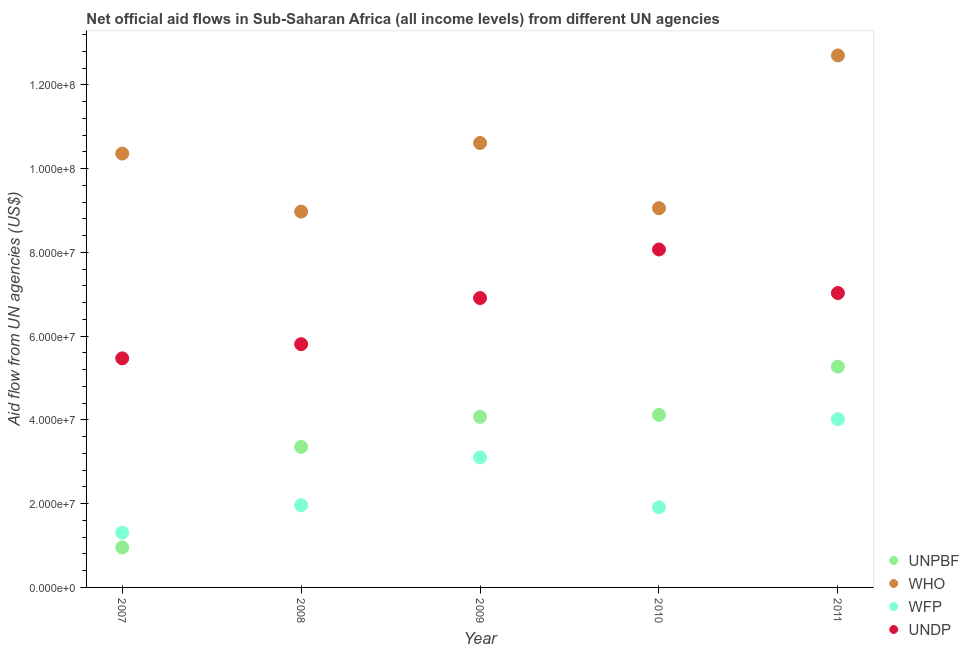What is the amount of aid given by unpbf in 2011?
Your response must be concise. 5.27e+07. Across all years, what is the maximum amount of aid given by who?
Make the answer very short. 1.27e+08. Across all years, what is the minimum amount of aid given by who?
Give a very brief answer. 8.98e+07. What is the total amount of aid given by who in the graph?
Make the answer very short. 5.17e+08. What is the difference between the amount of aid given by who in 2007 and that in 2009?
Offer a very short reply. -2.53e+06. What is the difference between the amount of aid given by unpbf in 2011 and the amount of aid given by undp in 2007?
Ensure brevity in your answer.  -1.98e+06. What is the average amount of aid given by wfp per year?
Give a very brief answer. 2.46e+07. In the year 2010, what is the difference between the amount of aid given by who and amount of aid given by undp?
Keep it short and to the point. 9.86e+06. In how many years, is the amount of aid given by who greater than 120000000 US$?
Offer a terse response. 1. What is the ratio of the amount of aid given by wfp in 2007 to that in 2010?
Ensure brevity in your answer.  0.68. Is the difference between the amount of aid given by undp in 2007 and 2009 greater than the difference between the amount of aid given by wfp in 2007 and 2009?
Provide a succinct answer. Yes. What is the difference between the highest and the second highest amount of aid given by unpbf?
Make the answer very short. 1.15e+07. What is the difference between the highest and the lowest amount of aid given by unpbf?
Keep it short and to the point. 4.32e+07. In how many years, is the amount of aid given by wfp greater than the average amount of aid given by wfp taken over all years?
Your answer should be very brief. 2. Is the sum of the amount of aid given by undp in 2010 and 2011 greater than the maximum amount of aid given by unpbf across all years?
Keep it short and to the point. Yes. Does the amount of aid given by undp monotonically increase over the years?
Your answer should be compact. No. Is the amount of aid given by unpbf strictly greater than the amount of aid given by who over the years?
Your answer should be compact. No. How many years are there in the graph?
Provide a short and direct response. 5. What is the difference between two consecutive major ticks on the Y-axis?
Your response must be concise. 2.00e+07. Are the values on the major ticks of Y-axis written in scientific E-notation?
Offer a very short reply. Yes. Where does the legend appear in the graph?
Offer a very short reply. Bottom right. How are the legend labels stacked?
Keep it short and to the point. Vertical. What is the title of the graph?
Give a very brief answer. Net official aid flows in Sub-Saharan Africa (all income levels) from different UN agencies. What is the label or title of the X-axis?
Ensure brevity in your answer.  Year. What is the label or title of the Y-axis?
Your answer should be compact. Aid flow from UN agencies (US$). What is the Aid flow from UN agencies (US$) of UNPBF in 2007?
Provide a short and direct response. 9.55e+06. What is the Aid flow from UN agencies (US$) in WHO in 2007?
Keep it short and to the point. 1.04e+08. What is the Aid flow from UN agencies (US$) of WFP in 2007?
Your response must be concise. 1.31e+07. What is the Aid flow from UN agencies (US$) of UNDP in 2007?
Provide a succinct answer. 5.47e+07. What is the Aid flow from UN agencies (US$) of UNPBF in 2008?
Keep it short and to the point. 3.36e+07. What is the Aid flow from UN agencies (US$) of WHO in 2008?
Give a very brief answer. 8.98e+07. What is the Aid flow from UN agencies (US$) of WFP in 2008?
Offer a very short reply. 1.96e+07. What is the Aid flow from UN agencies (US$) of UNDP in 2008?
Offer a terse response. 5.81e+07. What is the Aid flow from UN agencies (US$) in UNPBF in 2009?
Keep it short and to the point. 4.07e+07. What is the Aid flow from UN agencies (US$) of WHO in 2009?
Your answer should be very brief. 1.06e+08. What is the Aid flow from UN agencies (US$) in WFP in 2009?
Provide a succinct answer. 3.10e+07. What is the Aid flow from UN agencies (US$) of UNDP in 2009?
Provide a succinct answer. 6.91e+07. What is the Aid flow from UN agencies (US$) in UNPBF in 2010?
Offer a terse response. 4.12e+07. What is the Aid flow from UN agencies (US$) of WHO in 2010?
Make the answer very short. 9.06e+07. What is the Aid flow from UN agencies (US$) in WFP in 2010?
Your answer should be compact. 1.91e+07. What is the Aid flow from UN agencies (US$) in UNDP in 2010?
Your answer should be very brief. 8.07e+07. What is the Aid flow from UN agencies (US$) of UNPBF in 2011?
Give a very brief answer. 5.27e+07. What is the Aid flow from UN agencies (US$) in WHO in 2011?
Offer a very short reply. 1.27e+08. What is the Aid flow from UN agencies (US$) of WFP in 2011?
Ensure brevity in your answer.  4.02e+07. What is the Aid flow from UN agencies (US$) of UNDP in 2011?
Your answer should be compact. 7.03e+07. Across all years, what is the maximum Aid flow from UN agencies (US$) of UNPBF?
Your answer should be compact. 5.27e+07. Across all years, what is the maximum Aid flow from UN agencies (US$) in WHO?
Your answer should be compact. 1.27e+08. Across all years, what is the maximum Aid flow from UN agencies (US$) in WFP?
Your response must be concise. 4.02e+07. Across all years, what is the maximum Aid flow from UN agencies (US$) of UNDP?
Ensure brevity in your answer.  8.07e+07. Across all years, what is the minimum Aid flow from UN agencies (US$) of UNPBF?
Your response must be concise. 9.55e+06. Across all years, what is the minimum Aid flow from UN agencies (US$) of WHO?
Make the answer very short. 8.98e+07. Across all years, what is the minimum Aid flow from UN agencies (US$) in WFP?
Ensure brevity in your answer.  1.31e+07. Across all years, what is the minimum Aid flow from UN agencies (US$) of UNDP?
Give a very brief answer. 5.47e+07. What is the total Aid flow from UN agencies (US$) of UNPBF in the graph?
Give a very brief answer. 1.78e+08. What is the total Aid flow from UN agencies (US$) of WHO in the graph?
Your response must be concise. 5.17e+08. What is the total Aid flow from UN agencies (US$) in WFP in the graph?
Your answer should be very brief. 1.23e+08. What is the total Aid flow from UN agencies (US$) in UNDP in the graph?
Your answer should be very brief. 3.33e+08. What is the difference between the Aid flow from UN agencies (US$) in UNPBF in 2007 and that in 2008?
Offer a very short reply. -2.40e+07. What is the difference between the Aid flow from UN agencies (US$) in WHO in 2007 and that in 2008?
Offer a very short reply. 1.39e+07. What is the difference between the Aid flow from UN agencies (US$) of WFP in 2007 and that in 2008?
Give a very brief answer. -6.53e+06. What is the difference between the Aid flow from UN agencies (US$) of UNDP in 2007 and that in 2008?
Your response must be concise. -3.39e+06. What is the difference between the Aid flow from UN agencies (US$) of UNPBF in 2007 and that in 2009?
Your answer should be compact. -3.12e+07. What is the difference between the Aid flow from UN agencies (US$) of WHO in 2007 and that in 2009?
Ensure brevity in your answer.  -2.53e+06. What is the difference between the Aid flow from UN agencies (US$) of WFP in 2007 and that in 2009?
Offer a very short reply. -1.80e+07. What is the difference between the Aid flow from UN agencies (US$) of UNDP in 2007 and that in 2009?
Make the answer very short. -1.44e+07. What is the difference between the Aid flow from UN agencies (US$) of UNPBF in 2007 and that in 2010?
Provide a short and direct response. -3.17e+07. What is the difference between the Aid flow from UN agencies (US$) in WHO in 2007 and that in 2010?
Keep it short and to the point. 1.30e+07. What is the difference between the Aid flow from UN agencies (US$) in WFP in 2007 and that in 2010?
Your response must be concise. -6.06e+06. What is the difference between the Aid flow from UN agencies (US$) of UNDP in 2007 and that in 2010?
Provide a succinct answer. -2.60e+07. What is the difference between the Aid flow from UN agencies (US$) of UNPBF in 2007 and that in 2011?
Ensure brevity in your answer.  -4.32e+07. What is the difference between the Aid flow from UN agencies (US$) of WHO in 2007 and that in 2011?
Keep it short and to the point. -2.34e+07. What is the difference between the Aid flow from UN agencies (US$) in WFP in 2007 and that in 2011?
Offer a very short reply. -2.71e+07. What is the difference between the Aid flow from UN agencies (US$) in UNDP in 2007 and that in 2011?
Provide a short and direct response. -1.56e+07. What is the difference between the Aid flow from UN agencies (US$) in UNPBF in 2008 and that in 2009?
Provide a succinct answer. -7.17e+06. What is the difference between the Aid flow from UN agencies (US$) in WHO in 2008 and that in 2009?
Your answer should be very brief. -1.64e+07. What is the difference between the Aid flow from UN agencies (US$) in WFP in 2008 and that in 2009?
Your response must be concise. -1.14e+07. What is the difference between the Aid flow from UN agencies (US$) of UNDP in 2008 and that in 2009?
Make the answer very short. -1.10e+07. What is the difference between the Aid flow from UN agencies (US$) of UNPBF in 2008 and that in 2010?
Keep it short and to the point. -7.64e+06. What is the difference between the Aid flow from UN agencies (US$) of WHO in 2008 and that in 2010?
Ensure brevity in your answer.  -8.10e+05. What is the difference between the Aid flow from UN agencies (US$) of UNDP in 2008 and that in 2010?
Make the answer very short. -2.26e+07. What is the difference between the Aid flow from UN agencies (US$) in UNPBF in 2008 and that in 2011?
Make the answer very short. -1.92e+07. What is the difference between the Aid flow from UN agencies (US$) of WHO in 2008 and that in 2011?
Your answer should be very brief. -3.73e+07. What is the difference between the Aid flow from UN agencies (US$) in WFP in 2008 and that in 2011?
Keep it short and to the point. -2.06e+07. What is the difference between the Aid flow from UN agencies (US$) in UNDP in 2008 and that in 2011?
Make the answer very short. -1.22e+07. What is the difference between the Aid flow from UN agencies (US$) in UNPBF in 2009 and that in 2010?
Provide a succinct answer. -4.70e+05. What is the difference between the Aid flow from UN agencies (US$) in WHO in 2009 and that in 2010?
Your answer should be compact. 1.56e+07. What is the difference between the Aid flow from UN agencies (US$) in WFP in 2009 and that in 2010?
Offer a terse response. 1.19e+07. What is the difference between the Aid flow from UN agencies (US$) in UNDP in 2009 and that in 2010?
Your answer should be very brief. -1.16e+07. What is the difference between the Aid flow from UN agencies (US$) in UNPBF in 2009 and that in 2011?
Make the answer very short. -1.20e+07. What is the difference between the Aid flow from UN agencies (US$) of WHO in 2009 and that in 2011?
Provide a short and direct response. -2.09e+07. What is the difference between the Aid flow from UN agencies (US$) of WFP in 2009 and that in 2011?
Give a very brief answer. -9.14e+06. What is the difference between the Aid flow from UN agencies (US$) in UNDP in 2009 and that in 2011?
Ensure brevity in your answer.  -1.20e+06. What is the difference between the Aid flow from UN agencies (US$) in UNPBF in 2010 and that in 2011?
Provide a succinct answer. -1.15e+07. What is the difference between the Aid flow from UN agencies (US$) in WHO in 2010 and that in 2011?
Keep it short and to the point. -3.65e+07. What is the difference between the Aid flow from UN agencies (US$) in WFP in 2010 and that in 2011?
Keep it short and to the point. -2.10e+07. What is the difference between the Aid flow from UN agencies (US$) in UNDP in 2010 and that in 2011?
Provide a succinct answer. 1.04e+07. What is the difference between the Aid flow from UN agencies (US$) in UNPBF in 2007 and the Aid flow from UN agencies (US$) in WHO in 2008?
Your response must be concise. -8.02e+07. What is the difference between the Aid flow from UN agencies (US$) in UNPBF in 2007 and the Aid flow from UN agencies (US$) in WFP in 2008?
Ensure brevity in your answer.  -1.01e+07. What is the difference between the Aid flow from UN agencies (US$) in UNPBF in 2007 and the Aid flow from UN agencies (US$) in UNDP in 2008?
Your response must be concise. -4.86e+07. What is the difference between the Aid flow from UN agencies (US$) in WHO in 2007 and the Aid flow from UN agencies (US$) in WFP in 2008?
Keep it short and to the point. 8.40e+07. What is the difference between the Aid flow from UN agencies (US$) of WHO in 2007 and the Aid flow from UN agencies (US$) of UNDP in 2008?
Your answer should be very brief. 4.55e+07. What is the difference between the Aid flow from UN agencies (US$) in WFP in 2007 and the Aid flow from UN agencies (US$) in UNDP in 2008?
Offer a terse response. -4.50e+07. What is the difference between the Aid flow from UN agencies (US$) in UNPBF in 2007 and the Aid flow from UN agencies (US$) in WHO in 2009?
Provide a short and direct response. -9.66e+07. What is the difference between the Aid flow from UN agencies (US$) in UNPBF in 2007 and the Aid flow from UN agencies (US$) in WFP in 2009?
Give a very brief answer. -2.15e+07. What is the difference between the Aid flow from UN agencies (US$) of UNPBF in 2007 and the Aid flow from UN agencies (US$) of UNDP in 2009?
Provide a short and direct response. -5.96e+07. What is the difference between the Aid flow from UN agencies (US$) in WHO in 2007 and the Aid flow from UN agencies (US$) in WFP in 2009?
Keep it short and to the point. 7.26e+07. What is the difference between the Aid flow from UN agencies (US$) of WHO in 2007 and the Aid flow from UN agencies (US$) of UNDP in 2009?
Your answer should be compact. 3.45e+07. What is the difference between the Aid flow from UN agencies (US$) of WFP in 2007 and the Aid flow from UN agencies (US$) of UNDP in 2009?
Offer a very short reply. -5.60e+07. What is the difference between the Aid flow from UN agencies (US$) of UNPBF in 2007 and the Aid flow from UN agencies (US$) of WHO in 2010?
Your response must be concise. -8.10e+07. What is the difference between the Aid flow from UN agencies (US$) in UNPBF in 2007 and the Aid flow from UN agencies (US$) in WFP in 2010?
Your response must be concise. -9.59e+06. What is the difference between the Aid flow from UN agencies (US$) of UNPBF in 2007 and the Aid flow from UN agencies (US$) of UNDP in 2010?
Keep it short and to the point. -7.12e+07. What is the difference between the Aid flow from UN agencies (US$) in WHO in 2007 and the Aid flow from UN agencies (US$) in WFP in 2010?
Give a very brief answer. 8.45e+07. What is the difference between the Aid flow from UN agencies (US$) in WHO in 2007 and the Aid flow from UN agencies (US$) in UNDP in 2010?
Offer a very short reply. 2.29e+07. What is the difference between the Aid flow from UN agencies (US$) of WFP in 2007 and the Aid flow from UN agencies (US$) of UNDP in 2010?
Make the answer very short. -6.76e+07. What is the difference between the Aid flow from UN agencies (US$) of UNPBF in 2007 and the Aid flow from UN agencies (US$) of WHO in 2011?
Your answer should be compact. -1.18e+08. What is the difference between the Aid flow from UN agencies (US$) in UNPBF in 2007 and the Aid flow from UN agencies (US$) in WFP in 2011?
Keep it short and to the point. -3.06e+07. What is the difference between the Aid flow from UN agencies (US$) in UNPBF in 2007 and the Aid flow from UN agencies (US$) in UNDP in 2011?
Keep it short and to the point. -6.08e+07. What is the difference between the Aid flow from UN agencies (US$) of WHO in 2007 and the Aid flow from UN agencies (US$) of WFP in 2011?
Provide a succinct answer. 6.34e+07. What is the difference between the Aid flow from UN agencies (US$) of WHO in 2007 and the Aid flow from UN agencies (US$) of UNDP in 2011?
Your answer should be compact. 3.33e+07. What is the difference between the Aid flow from UN agencies (US$) in WFP in 2007 and the Aid flow from UN agencies (US$) in UNDP in 2011?
Offer a very short reply. -5.72e+07. What is the difference between the Aid flow from UN agencies (US$) in UNPBF in 2008 and the Aid flow from UN agencies (US$) in WHO in 2009?
Your response must be concise. -7.26e+07. What is the difference between the Aid flow from UN agencies (US$) of UNPBF in 2008 and the Aid flow from UN agencies (US$) of WFP in 2009?
Your answer should be very brief. 2.53e+06. What is the difference between the Aid flow from UN agencies (US$) in UNPBF in 2008 and the Aid flow from UN agencies (US$) in UNDP in 2009?
Your answer should be compact. -3.55e+07. What is the difference between the Aid flow from UN agencies (US$) of WHO in 2008 and the Aid flow from UN agencies (US$) of WFP in 2009?
Provide a succinct answer. 5.87e+07. What is the difference between the Aid flow from UN agencies (US$) in WHO in 2008 and the Aid flow from UN agencies (US$) in UNDP in 2009?
Your answer should be compact. 2.06e+07. What is the difference between the Aid flow from UN agencies (US$) in WFP in 2008 and the Aid flow from UN agencies (US$) in UNDP in 2009?
Keep it short and to the point. -4.95e+07. What is the difference between the Aid flow from UN agencies (US$) in UNPBF in 2008 and the Aid flow from UN agencies (US$) in WHO in 2010?
Make the answer very short. -5.70e+07. What is the difference between the Aid flow from UN agencies (US$) in UNPBF in 2008 and the Aid flow from UN agencies (US$) in WFP in 2010?
Offer a terse response. 1.44e+07. What is the difference between the Aid flow from UN agencies (US$) of UNPBF in 2008 and the Aid flow from UN agencies (US$) of UNDP in 2010?
Ensure brevity in your answer.  -4.71e+07. What is the difference between the Aid flow from UN agencies (US$) of WHO in 2008 and the Aid flow from UN agencies (US$) of WFP in 2010?
Make the answer very short. 7.06e+07. What is the difference between the Aid flow from UN agencies (US$) of WHO in 2008 and the Aid flow from UN agencies (US$) of UNDP in 2010?
Provide a short and direct response. 9.05e+06. What is the difference between the Aid flow from UN agencies (US$) of WFP in 2008 and the Aid flow from UN agencies (US$) of UNDP in 2010?
Your response must be concise. -6.11e+07. What is the difference between the Aid flow from UN agencies (US$) in UNPBF in 2008 and the Aid flow from UN agencies (US$) in WHO in 2011?
Your answer should be very brief. -9.35e+07. What is the difference between the Aid flow from UN agencies (US$) in UNPBF in 2008 and the Aid flow from UN agencies (US$) in WFP in 2011?
Provide a succinct answer. -6.61e+06. What is the difference between the Aid flow from UN agencies (US$) of UNPBF in 2008 and the Aid flow from UN agencies (US$) of UNDP in 2011?
Your response must be concise. -3.67e+07. What is the difference between the Aid flow from UN agencies (US$) in WHO in 2008 and the Aid flow from UN agencies (US$) in WFP in 2011?
Your answer should be compact. 4.96e+07. What is the difference between the Aid flow from UN agencies (US$) of WHO in 2008 and the Aid flow from UN agencies (US$) of UNDP in 2011?
Give a very brief answer. 1.94e+07. What is the difference between the Aid flow from UN agencies (US$) of WFP in 2008 and the Aid flow from UN agencies (US$) of UNDP in 2011?
Your answer should be compact. -5.07e+07. What is the difference between the Aid flow from UN agencies (US$) in UNPBF in 2009 and the Aid flow from UN agencies (US$) in WHO in 2010?
Provide a succinct answer. -4.98e+07. What is the difference between the Aid flow from UN agencies (US$) in UNPBF in 2009 and the Aid flow from UN agencies (US$) in WFP in 2010?
Provide a succinct answer. 2.16e+07. What is the difference between the Aid flow from UN agencies (US$) of UNPBF in 2009 and the Aid flow from UN agencies (US$) of UNDP in 2010?
Keep it short and to the point. -4.00e+07. What is the difference between the Aid flow from UN agencies (US$) in WHO in 2009 and the Aid flow from UN agencies (US$) in WFP in 2010?
Make the answer very short. 8.70e+07. What is the difference between the Aid flow from UN agencies (US$) of WHO in 2009 and the Aid flow from UN agencies (US$) of UNDP in 2010?
Provide a succinct answer. 2.54e+07. What is the difference between the Aid flow from UN agencies (US$) of WFP in 2009 and the Aid flow from UN agencies (US$) of UNDP in 2010?
Your response must be concise. -4.97e+07. What is the difference between the Aid flow from UN agencies (US$) in UNPBF in 2009 and the Aid flow from UN agencies (US$) in WHO in 2011?
Make the answer very short. -8.63e+07. What is the difference between the Aid flow from UN agencies (US$) of UNPBF in 2009 and the Aid flow from UN agencies (US$) of WFP in 2011?
Keep it short and to the point. 5.60e+05. What is the difference between the Aid flow from UN agencies (US$) in UNPBF in 2009 and the Aid flow from UN agencies (US$) in UNDP in 2011?
Make the answer very short. -2.96e+07. What is the difference between the Aid flow from UN agencies (US$) in WHO in 2009 and the Aid flow from UN agencies (US$) in WFP in 2011?
Your answer should be very brief. 6.60e+07. What is the difference between the Aid flow from UN agencies (US$) in WHO in 2009 and the Aid flow from UN agencies (US$) in UNDP in 2011?
Offer a very short reply. 3.58e+07. What is the difference between the Aid flow from UN agencies (US$) of WFP in 2009 and the Aid flow from UN agencies (US$) of UNDP in 2011?
Offer a very short reply. -3.93e+07. What is the difference between the Aid flow from UN agencies (US$) of UNPBF in 2010 and the Aid flow from UN agencies (US$) of WHO in 2011?
Make the answer very short. -8.58e+07. What is the difference between the Aid flow from UN agencies (US$) in UNPBF in 2010 and the Aid flow from UN agencies (US$) in WFP in 2011?
Your response must be concise. 1.03e+06. What is the difference between the Aid flow from UN agencies (US$) of UNPBF in 2010 and the Aid flow from UN agencies (US$) of UNDP in 2011?
Your answer should be very brief. -2.91e+07. What is the difference between the Aid flow from UN agencies (US$) of WHO in 2010 and the Aid flow from UN agencies (US$) of WFP in 2011?
Your response must be concise. 5.04e+07. What is the difference between the Aid flow from UN agencies (US$) of WHO in 2010 and the Aid flow from UN agencies (US$) of UNDP in 2011?
Offer a very short reply. 2.03e+07. What is the difference between the Aid flow from UN agencies (US$) of WFP in 2010 and the Aid flow from UN agencies (US$) of UNDP in 2011?
Your answer should be compact. -5.12e+07. What is the average Aid flow from UN agencies (US$) in UNPBF per year?
Your answer should be compact. 3.56e+07. What is the average Aid flow from UN agencies (US$) in WHO per year?
Ensure brevity in your answer.  1.03e+08. What is the average Aid flow from UN agencies (US$) in WFP per year?
Offer a very short reply. 2.46e+07. What is the average Aid flow from UN agencies (US$) of UNDP per year?
Provide a succinct answer. 6.66e+07. In the year 2007, what is the difference between the Aid flow from UN agencies (US$) in UNPBF and Aid flow from UN agencies (US$) in WHO?
Your answer should be compact. -9.41e+07. In the year 2007, what is the difference between the Aid flow from UN agencies (US$) in UNPBF and Aid flow from UN agencies (US$) in WFP?
Make the answer very short. -3.53e+06. In the year 2007, what is the difference between the Aid flow from UN agencies (US$) of UNPBF and Aid flow from UN agencies (US$) of UNDP?
Give a very brief answer. -4.52e+07. In the year 2007, what is the difference between the Aid flow from UN agencies (US$) in WHO and Aid flow from UN agencies (US$) in WFP?
Provide a succinct answer. 9.05e+07. In the year 2007, what is the difference between the Aid flow from UN agencies (US$) of WHO and Aid flow from UN agencies (US$) of UNDP?
Keep it short and to the point. 4.89e+07. In the year 2007, what is the difference between the Aid flow from UN agencies (US$) of WFP and Aid flow from UN agencies (US$) of UNDP?
Make the answer very short. -4.16e+07. In the year 2008, what is the difference between the Aid flow from UN agencies (US$) in UNPBF and Aid flow from UN agencies (US$) in WHO?
Offer a very short reply. -5.62e+07. In the year 2008, what is the difference between the Aid flow from UN agencies (US$) of UNPBF and Aid flow from UN agencies (US$) of WFP?
Provide a short and direct response. 1.40e+07. In the year 2008, what is the difference between the Aid flow from UN agencies (US$) in UNPBF and Aid flow from UN agencies (US$) in UNDP?
Offer a terse response. -2.45e+07. In the year 2008, what is the difference between the Aid flow from UN agencies (US$) in WHO and Aid flow from UN agencies (US$) in WFP?
Make the answer very short. 7.02e+07. In the year 2008, what is the difference between the Aid flow from UN agencies (US$) of WHO and Aid flow from UN agencies (US$) of UNDP?
Ensure brevity in your answer.  3.17e+07. In the year 2008, what is the difference between the Aid flow from UN agencies (US$) in WFP and Aid flow from UN agencies (US$) in UNDP?
Give a very brief answer. -3.85e+07. In the year 2009, what is the difference between the Aid flow from UN agencies (US$) in UNPBF and Aid flow from UN agencies (US$) in WHO?
Give a very brief answer. -6.54e+07. In the year 2009, what is the difference between the Aid flow from UN agencies (US$) of UNPBF and Aid flow from UN agencies (US$) of WFP?
Keep it short and to the point. 9.70e+06. In the year 2009, what is the difference between the Aid flow from UN agencies (US$) in UNPBF and Aid flow from UN agencies (US$) in UNDP?
Your answer should be very brief. -2.84e+07. In the year 2009, what is the difference between the Aid flow from UN agencies (US$) of WHO and Aid flow from UN agencies (US$) of WFP?
Keep it short and to the point. 7.51e+07. In the year 2009, what is the difference between the Aid flow from UN agencies (US$) in WHO and Aid flow from UN agencies (US$) in UNDP?
Make the answer very short. 3.70e+07. In the year 2009, what is the difference between the Aid flow from UN agencies (US$) in WFP and Aid flow from UN agencies (US$) in UNDP?
Your response must be concise. -3.81e+07. In the year 2010, what is the difference between the Aid flow from UN agencies (US$) of UNPBF and Aid flow from UN agencies (US$) of WHO?
Provide a short and direct response. -4.94e+07. In the year 2010, what is the difference between the Aid flow from UN agencies (US$) of UNPBF and Aid flow from UN agencies (US$) of WFP?
Keep it short and to the point. 2.21e+07. In the year 2010, what is the difference between the Aid flow from UN agencies (US$) in UNPBF and Aid flow from UN agencies (US$) in UNDP?
Your answer should be very brief. -3.95e+07. In the year 2010, what is the difference between the Aid flow from UN agencies (US$) in WHO and Aid flow from UN agencies (US$) in WFP?
Offer a very short reply. 7.14e+07. In the year 2010, what is the difference between the Aid flow from UN agencies (US$) of WHO and Aid flow from UN agencies (US$) of UNDP?
Offer a very short reply. 9.86e+06. In the year 2010, what is the difference between the Aid flow from UN agencies (US$) of WFP and Aid flow from UN agencies (US$) of UNDP?
Offer a very short reply. -6.16e+07. In the year 2011, what is the difference between the Aid flow from UN agencies (US$) of UNPBF and Aid flow from UN agencies (US$) of WHO?
Your response must be concise. -7.43e+07. In the year 2011, what is the difference between the Aid flow from UN agencies (US$) of UNPBF and Aid flow from UN agencies (US$) of WFP?
Make the answer very short. 1.26e+07. In the year 2011, what is the difference between the Aid flow from UN agencies (US$) of UNPBF and Aid flow from UN agencies (US$) of UNDP?
Make the answer very short. -1.76e+07. In the year 2011, what is the difference between the Aid flow from UN agencies (US$) in WHO and Aid flow from UN agencies (US$) in WFP?
Offer a terse response. 8.69e+07. In the year 2011, what is the difference between the Aid flow from UN agencies (US$) in WHO and Aid flow from UN agencies (US$) in UNDP?
Offer a very short reply. 5.68e+07. In the year 2011, what is the difference between the Aid flow from UN agencies (US$) of WFP and Aid flow from UN agencies (US$) of UNDP?
Give a very brief answer. -3.01e+07. What is the ratio of the Aid flow from UN agencies (US$) in UNPBF in 2007 to that in 2008?
Keep it short and to the point. 0.28. What is the ratio of the Aid flow from UN agencies (US$) in WHO in 2007 to that in 2008?
Ensure brevity in your answer.  1.15. What is the ratio of the Aid flow from UN agencies (US$) of WFP in 2007 to that in 2008?
Ensure brevity in your answer.  0.67. What is the ratio of the Aid flow from UN agencies (US$) of UNDP in 2007 to that in 2008?
Make the answer very short. 0.94. What is the ratio of the Aid flow from UN agencies (US$) in UNPBF in 2007 to that in 2009?
Your answer should be compact. 0.23. What is the ratio of the Aid flow from UN agencies (US$) of WHO in 2007 to that in 2009?
Offer a very short reply. 0.98. What is the ratio of the Aid flow from UN agencies (US$) in WFP in 2007 to that in 2009?
Your answer should be compact. 0.42. What is the ratio of the Aid flow from UN agencies (US$) in UNDP in 2007 to that in 2009?
Provide a short and direct response. 0.79. What is the ratio of the Aid flow from UN agencies (US$) in UNPBF in 2007 to that in 2010?
Your answer should be compact. 0.23. What is the ratio of the Aid flow from UN agencies (US$) in WHO in 2007 to that in 2010?
Your answer should be very brief. 1.14. What is the ratio of the Aid flow from UN agencies (US$) in WFP in 2007 to that in 2010?
Give a very brief answer. 0.68. What is the ratio of the Aid flow from UN agencies (US$) in UNDP in 2007 to that in 2010?
Provide a short and direct response. 0.68. What is the ratio of the Aid flow from UN agencies (US$) in UNPBF in 2007 to that in 2011?
Make the answer very short. 0.18. What is the ratio of the Aid flow from UN agencies (US$) in WHO in 2007 to that in 2011?
Provide a short and direct response. 0.82. What is the ratio of the Aid flow from UN agencies (US$) in WFP in 2007 to that in 2011?
Ensure brevity in your answer.  0.33. What is the ratio of the Aid flow from UN agencies (US$) in UNDP in 2007 to that in 2011?
Offer a terse response. 0.78. What is the ratio of the Aid flow from UN agencies (US$) in UNPBF in 2008 to that in 2009?
Make the answer very short. 0.82. What is the ratio of the Aid flow from UN agencies (US$) of WHO in 2008 to that in 2009?
Offer a very short reply. 0.85. What is the ratio of the Aid flow from UN agencies (US$) of WFP in 2008 to that in 2009?
Offer a very short reply. 0.63. What is the ratio of the Aid flow from UN agencies (US$) of UNDP in 2008 to that in 2009?
Your answer should be compact. 0.84. What is the ratio of the Aid flow from UN agencies (US$) of UNPBF in 2008 to that in 2010?
Your answer should be very brief. 0.81. What is the ratio of the Aid flow from UN agencies (US$) of WHO in 2008 to that in 2010?
Provide a succinct answer. 0.99. What is the ratio of the Aid flow from UN agencies (US$) of WFP in 2008 to that in 2010?
Keep it short and to the point. 1.02. What is the ratio of the Aid flow from UN agencies (US$) in UNDP in 2008 to that in 2010?
Provide a succinct answer. 0.72. What is the ratio of the Aid flow from UN agencies (US$) in UNPBF in 2008 to that in 2011?
Keep it short and to the point. 0.64. What is the ratio of the Aid flow from UN agencies (US$) of WHO in 2008 to that in 2011?
Keep it short and to the point. 0.71. What is the ratio of the Aid flow from UN agencies (US$) of WFP in 2008 to that in 2011?
Give a very brief answer. 0.49. What is the ratio of the Aid flow from UN agencies (US$) of UNDP in 2008 to that in 2011?
Your answer should be very brief. 0.83. What is the ratio of the Aid flow from UN agencies (US$) in WHO in 2009 to that in 2010?
Make the answer very short. 1.17. What is the ratio of the Aid flow from UN agencies (US$) of WFP in 2009 to that in 2010?
Offer a terse response. 1.62. What is the ratio of the Aid flow from UN agencies (US$) of UNDP in 2009 to that in 2010?
Ensure brevity in your answer.  0.86. What is the ratio of the Aid flow from UN agencies (US$) in UNPBF in 2009 to that in 2011?
Offer a terse response. 0.77. What is the ratio of the Aid flow from UN agencies (US$) of WHO in 2009 to that in 2011?
Make the answer very short. 0.84. What is the ratio of the Aid flow from UN agencies (US$) in WFP in 2009 to that in 2011?
Offer a very short reply. 0.77. What is the ratio of the Aid flow from UN agencies (US$) in UNDP in 2009 to that in 2011?
Keep it short and to the point. 0.98. What is the ratio of the Aid flow from UN agencies (US$) of UNPBF in 2010 to that in 2011?
Your response must be concise. 0.78. What is the ratio of the Aid flow from UN agencies (US$) of WHO in 2010 to that in 2011?
Provide a short and direct response. 0.71. What is the ratio of the Aid flow from UN agencies (US$) in WFP in 2010 to that in 2011?
Your response must be concise. 0.48. What is the ratio of the Aid flow from UN agencies (US$) of UNDP in 2010 to that in 2011?
Provide a short and direct response. 1.15. What is the difference between the highest and the second highest Aid flow from UN agencies (US$) of UNPBF?
Ensure brevity in your answer.  1.15e+07. What is the difference between the highest and the second highest Aid flow from UN agencies (US$) of WHO?
Give a very brief answer. 2.09e+07. What is the difference between the highest and the second highest Aid flow from UN agencies (US$) of WFP?
Your answer should be very brief. 9.14e+06. What is the difference between the highest and the second highest Aid flow from UN agencies (US$) in UNDP?
Make the answer very short. 1.04e+07. What is the difference between the highest and the lowest Aid flow from UN agencies (US$) of UNPBF?
Give a very brief answer. 4.32e+07. What is the difference between the highest and the lowest Aid flow from UN agencies (US$) of WHO?
Give a very brief answer. 3.73e+07. What is the difference between the highest and the lowest Aid flow from UN agencies (US$) in WFP?
Offer a terse response. 2.71e+07. What is the difference between the highest and the lowest Aid flow from UN agencies (US$) in UNDP?
Your response must be concise. 2.60e+07. 